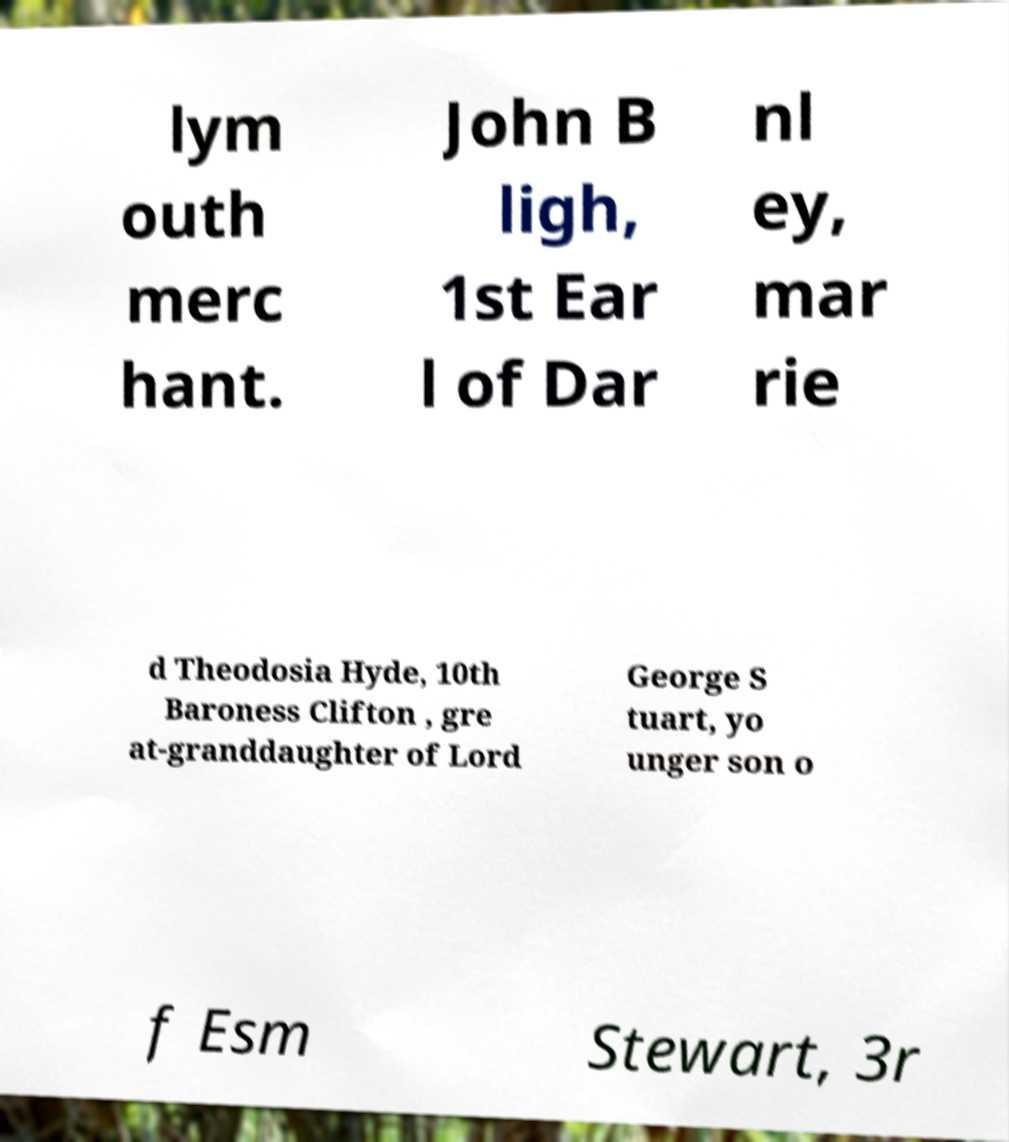What messages or text are displayed in this image? I need them in a readable, typed format. lym outh merc hant. John B ligh, 1st Ear l of Dar nl ey, mar rie d Theodosia Hyde, 10th Baroness Clifton , gre at-granddaughter of Lord George S tuart, yo unger son o f Esm Stewart, 3r 